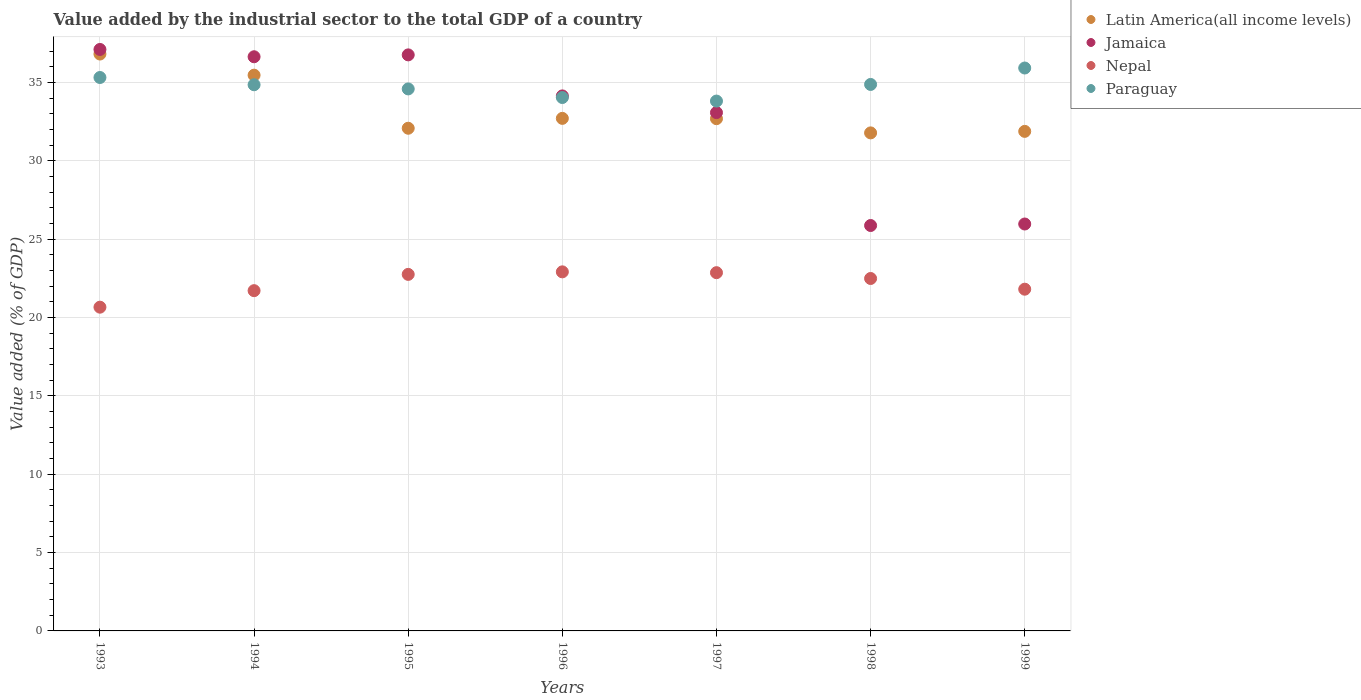What is the value added by the industrial sector to the total GDP in Nepal in 1993?
Offer a very short reply. 20.66. Across all years, what is the maximum value added by the industrial sector to the total GDP in Nepal?
Offer a terse response. 22.92. Across all years, what is the minimum value added by the industrial sector to the total GDP in Nepal?
Provide a succinct answer. 20.66. What is the total value added by the industrial sector to the total GDP in Nepal in the graph?
Make the answer very short. 155.21. What is the difference between the value added by the industrial sector to the total GDP in Nepal in 1993 and that in 1999?
Ensure brevity in your answer.  -1.15. What is the difference between the value added by the industrial sector to the total GDP in Latin America(all income levels) in 1998 and the value added by the industrial sector to the total GDP in Paraguay in 1999?
Provide a succinct answer. -4.14. What is the average value added by the industrial sector to the total GDP in Jamaica per year?
Offer a terse response. 32.8. In the year 1994, what is the difference between the value added by the industrial sector to the total GDP in Paraguay and value added by the industrial sector to the total GDP in Latin America(all income levels)?
Ensure brevity in your answer.  -0.61. In how many years, is the value added by the industrial sector to the total GDP in Jamaica greater than 7 %?
Your response must be concise. 7. What is the ratio of the value added by the industrial sector to the total GDP in Paraguay in 1995 to that in 1996?
Offer a terse response. 1.02. What is the difference between the highest and the second highest value added by the industrial sector to the total GDP in Paraguay?
Offer a very short reply. 0.61. What is the difference between the highest and the lowest value added by the industrial sector to the total GDP in Jamaica?
Make the answer very short. 11.24. Is the sum of the value added by the industrial sector to the total GDP in Jamaica in 1995 and 1999 greater than the maximum value added by the industrial sector to the total GDP in Latin America(all income levels) across all years?
Give a very brief answer. Yes. Is it the case that in every year, the sum of the value added by the industrial sector to the total GDP in Jamaica and value added by the industrial sector to the total GDP in Nepal  is greater than the value added by the industrial sector to the total GDP in Paraguay?
Your answer should be compact. Yes. Does the value added by the industrial sector to the total GDP in Jamaica monotonically increase over the years?
Ensure brevity in your answer.  No. Is the value added by the industrial sector to the total GDP in Jamaica strictly less than the value added by the industrial sector to the total GDP in Latin America(all income levels) over the years?
Your answer should be compact. No. What is the difference between two consecutive major ticks on the Y-axis?
Offer a terse response. 5. Does the graph contain any zero values?
Ensure brevity in your answer.  No. Does the graph contain grids?
Offer a very short reply. Yes. How are the legend labels stacked?
Provide a short and direct response. Vertical. What is the title of the graph?
Offer a terse response. Value added by the industrial sector to the total GDP of a country. What is the label or title of the Y-axis?
Give a very brief answer. Value added (% of GDP). What is the Value added (% of GDP) of Latin America(all income levels) in 1993?
Your answer should be compact. 36.82. What is the Value added (% of GDP) of Jamaica in 1993?
Offer a very short reply. 37.11. What is the Value added (% of GDP) in Nepal in 1993?
Provide a succinct answer. 20.66. What is the Value added (% of GDP) in Paraguay in 1993?
Your answer should be very brief. 35.32. What is the Value added (% of GDP) in Latin America(all income levels) in 1994?
Give a very brief answer. 35.47. What is the Value added (% of GDP) of Jamaica in 1994?
Provide a succinct answer. 36.64. What is the Value added (% of GDP) of Nepal in 1994?
Ensure brevity in your answer.  21.72. What is the Value added (% of GDP) in Paraguay in 1994?
Ensure brevity in your answer.  34.86. What is the Value added (% of GDP) in Latin America(all income levels) in 1995?
Your answer should be very brief. 32.08. What is the Value added (% of GDP) of Jamaica in 1995?
Provide a succinct answer. 36.76. What is the Value added (% of GDP) of Nepal in 1995?
Ensure brevity in your answer.  22.75. What is the Value added (% of GDP) of Paraguay in 1995?
Ensure brevity in your answer.  34.59. What is the Value added (% of GDP) of Latin America(all income levels) in 1996?
Offer a terse response. 32.71. What is the Value added (% of GDP) of Jamaica in 1996?
Your answer should be compact. 34.14. What is the Value added (% of GDP) of Nepal in 1996?
Provide a succinct answer. 22.92. What is the Value added (% of GDP) of Paraguay in 1996?
Provide a short and direct response. 34.04. What is the Value added (% of GDP) of Latin America(all income levels) in 1997?
Ensure brevity in your answer.  32.69. What is the Value added (% of GDP) of Jamaica in 1997?
Your answer should be very brief. 33.08. What is the Value added (% of GDP) in Nepal in 1997?
Provide a succinct answer. 22.86. What is the Value added (% of GDP) in Paraguay in 1997?
Give a very brief answer. 33.82. What is the Value added (% of GDP) of Latin America(all income levels) in 1998?
Keep it short and to the point. 31.78. What is the Value added (% of GDP) of Jamaica in 1998?
Make the answer very short. 25.87. What is the Value added (% of GDP) in Nepal in 1998?
Your answer should be compact. 22.49. What is the Value added (% of GDP) of Paraguay in 1998?
Offer a very short reply. 34.88. What is the Value added (% of GDP) of Latin America(all income levels) in 1999?
Ensure brevity in your answer.  31.88. What is the Value added (% of GDP) in Jamaica in 1999?
Offer a very short reply. 25.97. What is the Value added (% of GDP) in Nepal in 1999?
Your answer should be compact. 21.81. What is the Value added (% of GDP) of Paraguay in 1999?
Your response must be concise. 35.93. Across all years, what is the maximum Value added (% of GDP) in Latin America(all income levels)?
Keep it short and to the point. 36.82. Across all years, what is the maximum Value added (% of GDP) in Jamaica?
Offer a terse response. 37.11. Across all years, what is the maximum Value added (% of GDP) in Nepal?
Offer a terse response. 22.92. Across all years, what is the maximum Value added (% of GDP) of Paraguay?
Give a very brief answer. 35.93. Across all years, what is the minimum Value added (% of GDP) of Latin America(all income levels)?
Give a very brief answer. 31.78. Across all years, what is the minimum Value added (% of GDP) in Jamaica?
Keep it short and to the point. 25.87. Across all years, what is the minimum Value added (% of GDP) of Nepal?
Provide a short and direct response. 20.66. Across all years, what is the minimum Value added (% of GDP) of Paraguay?
Your answer should be very brief. 33.82. What is the total Value added (% of GDP) in Latin America(all income levels) in the graph?
Offer a terse response. 233.44. What is the total Value added (% of GDP) in Jamaica in the graph?
Your response must be concise. 229.58. What is the total Value added (% of GDP) in Nepal in the graph?
Provide a succinct answer. 155.21. What is the total Value added (% of GDP) in Paraguay in the graph?
Provide a succinct answer. 243.43. What is the difference between the Value added (% of GDP) in Latin America(all income levels) in 1993 and that in 1994?
Your response must be concise. 1.35. What is the difference between the Value added (% of GDP) in Jamaica in 1993 and that in 1994?
Provide a succinct answer. 0.47. What is the difference between the Value added (% of GDP) of Nepal in 1993 and that in 1994?
Make the answer very short. -1.05. What is the difference between the Value added (% of GDP) in Paraguay in 1993 and that in 1994?
Provide a short and direct response. 0.46. What is the difference between the Value added (% of GDP) of Latin America(all income levels) in 1993 and that in 1995?
Make the answer very short. 4.74. What is the difference between the Value added (% of GDP) of Jamaica in 1993 and that in 1995?
Make the answer very short. 0.35. What is the difference between the Value added (% of GDP) of Nepal in 1993 and that in 1995?
Your answer should be compact. -2.09. What is the difference between the Value added (% of GDP) of Paraguay in 1993 and that in 1995?
Provide a succinct answer. 0.73. What is the difference between the Value added (% of GDP) of Latin America(all income levels) in 1993 and that in 1996?
Your answer should be very brief. 4.11. What is the difference between the Value added (% of GDP) in Jamaica in 1993 and that in 1996?
Your response must be concise. 2.96. What is the difference between the Value added (% of GDP) in Nepal in 1993 and that in 1996?
Your response must be concise. -2.25. What is the difference between the Value added (% of GDP) of Paraguay in 1993 and that in 1996?
Your answer should be very brief. 1.28. What is the difference between the Value added (% of GDP) in Latin America(all income levels) in 1993 and that in 1997?
Your answer should be very brief. 4.13. What is the difference between the Value added (% of GDP) in Jamaica in 1993 and that in 1997?
Your answer should be very brief. 4.03. What is the difference between the Value added (% of GDP) of Nepal in 1993 and that in 1997?
Provide a short and direct response. -2.2. What is the difference between the Value added (% of GDP) of Paraguay in 1993 and that in 1997?
Give a very brief answer. 1.5. What is the difference between the Value added (% of GDP) of Latin America(all income levels) in 1993 and that in 1998?
Your answer should be very brief. 5.03. What is the difference between the Value added (% of GDP) of Jamaica in 1993 and that in 1998?
Keep it short and to the point. 11.24. What is the difference between the Value added (% of GDP) of Nepal in 1993 and that in 1998?
Provide a succinct answer. -1.83. What is the difference between the Value added (% of GDP) of Paraguay in 1993 and that in 1998?
Keep it short and to the point. 0.44. What is the difference between the Value added (% of GDP) of Latin America(all income levels) in 1993 and that in 1999?
Keep it short and to the point. 4.94. What is the difference between the Value added (% of GDP) in Jamaica in 1993 and that in 1999?
Ensure brevity in your answer.  11.14. What is the difference between the Value added (% of GDP) of Nepal in 1993 and that in 1999?
Offer a terse response. -1.15. What is the difference between the Value added (% of GDP) in Paraguay in 1993 and that in 1999?
Your answer should be compact. -0.61. What is the difference between the Value added (% of GDP) in Latin America(all income levels) in 1994 and that in 1995?
Keep it short and to the point. 3.39. What is the difference between the Value added (% of GDP) in Jamaica in 1994 and that in 1995?
Give a very brief answer. -0.12. What is the difference between the Value added (% of GDP) of Nepal in 1994 and that in 1995?
Provide a succinct answer. -1.04. What is the difference between the Value added (% of GDP) in Paraguay in 1994 and that in 1995?
Your response must be concise. 0.27. What is the difference between the Value added (% of GDP) of Latin America(all income levels) in 1994 and that in 1996?
Provide a short and direct response. 2.76. What is the difference between the Value added (% of GDP) of Jamaica in 1994 and that in 1996?
Your response must be concise. 2.5. What is the difference between the Value added (% of GDP) of Nepal in 1994 and that in 1996?
Keep it short and to the point. -1.2. What is the difference between the Value added (% of GDP) in Paraguay in 1994 and that in 1996?
Your answer should be compact. 0.81. What is the difference between the Value added (% of GDP) of Latin America(all income levels) in 1994 and that in 1997?
Offer a terse response. 2.78. What is the difference between the Value added (% of GDP) of Jamaica in 1994 and that in 1997?
Your answer should be compact. 3.56. What is the difference between the Value added (% of GDP) in Nepal in 1994 and that in 1997?
Make the answer very short. -1.15. What is the difference between the Value added (% of GDP) in Paraguay in 1994 and that in 1997?
Your answer should be compact. 1.04. What is the difference between the Value added (% of GDP) in Latin America(all income levels) in 1994 and that in 1998?
Your answer should be compact. 3.68. What is the difference between the Value added (% of GDP) in Jamaica in 1994 and that in 1998?
Provide a succinct answer. 10.77. What is the difference between the Value added (% of GDP) in Nepal in 1994 and that in 1998?
Offer a very short reply. -0.78. What is the difference between the Value added (% of GDP) in Paraguay in 1994 and that in 1998?
Provide a short and direct response. -0.02. What is the difference between the Value added (% of GDP) of Latin America(all income levels) in 1994 and that in 1999?
Offer a terse response. 3.59. What is the difference between the Value added (% of GDP) of Jamaica in 1994 and that in 1999?
Make the answer very short. 10.67. What is the difference between the Value added (% of GDP) in Nepal in 1994 and that in 1999?
Your response must be concise. -0.09. What is the difference between the Value added (% of GDP) in Paraguay in 1994 and that in 1999?
Offer a terse response. -1.07. What is the difference between the Value added (% of GDP) of Latin America(all income levels) in 1995 and that in 1996?
Ensure brevity in your answer.  -0.63. What is the difference between the Value added (% of GDP) of Jamaica in 1995 and that in 1996?
Offer a very short reply. 2.62. What is the difference between the Value added (% of GDP) of Nepal in 1995 and that in 1996?
Offer a terse response. -0.16. What is the difference between the Value added (% of GDP) in Paraguay in 1995 and that in 1996?
Keep it short and to the point. 0.55. What is the difference between the Value added (% of GDP) in Latin America(all income levels) in 1995 and that in 1997?
Provide a short and direct response. -0.61. What is the difference between the Value added (% of GDP) in Jamaica in 1995 and that in 1997?
Your response must be concise. 3.68. What is the difference between the Value added (% of GDP) of Nepal in 1995 and that in 1997?
Your answer should be compact. -0.11. What is the difference between the Value added (% of GDP) in Paraguay in 1995 and that in 1997?
Make the answer very short. 0.78. What is the difference between the Value added (% of GDP) in Latin America(all income levels) in 1995 and that in 1998?
Make the answer very short. 0.3. What is the difference between the Value added (% of GDP) of Jamaica in 1995 and that in 1998?
Offer a very short reply. 10.89. What is the difference between the Value added (% of GDP) in Nepal in 1995 and that in 1998?
Keep it short and to the point. 0.26. What is the difference between the Value added (% of GDP) in Paraguay in 1995 and that in 1998?
Ensure brevity in your answer.  -0.29. What is the difference between the Value added (% of GDP) in Latin America(all income levels) in 1995 and that in 1999?
Make the answer very short. 0.2. What is the difference between the Value added (% of GDP) in Jamaica in 1995 and that in 1999?
Keep it short and to the point. 10.79. What is the difference between the Value added (% of GDP) of Nepal in 1995 and that in 1999?
Your answer should be very brief. 0.95. What is the difference between the Value added (% of GDP) of Paraguay in 1995 and that in 1999?
Your response must be concise. -1.33. What is the difference between the Value added (% of GDP) of Latin America(all income levels) in 1996 and that in 1997?
Provide a short and direct response. 0.02. What is the difference between the Value added (% of GDP) of Jamaica in 1996 and that in 1997?
Offer a very short reply. 1.07. What is the difference between the Value added (% of GDP) of Nepal in 1996 and that in 1997?
Offer a very short reply. 0.05. What is the difference between the Value added (% of GDP) in Paraguay in 1996 and that in 1997?
Keep it short and to the point. 0.23. What is the difference between the Value added (% of GDP) of Latin America(all income levels) in 1996 and that in 1998?
Ensure brevity in your answer.  0.93. What is the difference between the Value added (% of GDP) of Jamaica in 1996 and that in 1998?
Ensure brevity in your answer.  8.27. What is the difference between the Value added (% of GDP) in Nepal in 1996 and that in 1998?
Offer a terse response. 0.42. What is the difference between the Value added (% of GDP) in Paraguay in 1996 and that in 1998?
Offer a terse response. -0.83. What is the difference between the Value added (% of GDP) in Latin America(all income levels) in 1996 and that in 1999?
Your answer should be very brief. 0.83. What is the difference between the Value added (% of GDP) in Jamaica in 1996 and that in 1999?
Provide a succinct answer. 8.18. What is the difference between the Value added (% of GDP) in Nepal in 1996 and that in 1999?
Your response must be concise. 1.11. What is the difference between the Value added (% of GDP) in Paraguay in 1996 and that in 1999?
Keep it short and to the point. -1.88. What is the difference between the Value added (% of GDP) of Latin America(all income levels) in 1997 and that in 1998?
Make the answer very short. 0.91. What is the difference between the Value added (% of GDP) in Jamaica in 1997 and that in 1998?
Your answer should be compact. 7.21. What is the difference between the Value added (% of GDP) in Nepal in 1997 and that in 1998?
Offer a very short reply. 0.37. What is the difference between the Value added (% of GDP) of Paraguay in 1997 and that in 1998?
Offer a very short reply. -1.06. What is the difference between the Value added (% of GDP) of Latin America(all income levels) in 1997 and that in 1999?
Ensure brevity in your answer.  0.81. What is the difference between the Value added (% of GDP) in Jamaica in 1997 and that in 1999?
Provide a succinct answer. 7.11. What is the difference between the Value added (% of GDP) in Nepal in 1997 and that in 1999?
Provide a short and direct response. 1.05. What is the difference between the Value added (% of GDP) in Paraguay in 1997 and that in 1999?
Give a very brief answer. -2.11. What is the difference between the Value added (% of GDP) of Latin America(all income levels) in 1998 and that in 1999?
Your response must be concise. -0.1. What is the difference between the Value added (% of GDP) of Jamaica in 1998 and that in 1999?
Give a very brief answer. -0.1. What is the difference between the Value added (% of GDP) of Nepal in 1998 and that in 1999?
Ensure brevity in your answer.  0.68. What is the difference between the Value added (% of GDP) in Paraguay in 1998 and that in 1999?
Provide a succinct answer. -1.05. What is the difference between the Value added (% of GDP) in Latin America(all income levels) in 1993 and the Value added (% of GDP) in Jamaica in 1994?
Give a very brief answer. 0.17. What is the difference between the Value added (% of GDP) in Latin America(all income levels) in 1993 and the Value added (% of GDP) in Nepal in 1994?
Keep it short and to the point. 15.1. What is the difference between the Value added (% of GDP) of Latin America(all income levels) in 1993 and the Value added (% of GDP) of Paraguay in 1994?
Ensure brevity in your answer.  1.96. What is the difference between the Value added (% of GDP) of Jamaica in 1993 and the Value added (% of GDP) of Nepal in 1994?
Make the answer very short. 15.39. What is the difference between the Value added (% of GDP) in Jamaica in 1993 and the Value added (% of GDP) in Paraguay in 1994?
Your answer should be very brief. 2.25. What is the difference between the Value added (% of GDP) of Nepal in 1993 and the Value added (% of GDP) of Paraguay in 1994?
Offer a terse response. -14.2. What is the difference between the Value added (% of GDP) in Latin America(all income levels) in 1993 and the Value added (% of GDP) in Jamaica in 1995?
Provide a succinct answer. 0.05. What is the difference between the Value added (% of GDP) in Latin America(all income levels) in 1993 and the Value added (% of GDP) in Nepal in 1995?
Provide a succinct answer. 14.06. What is the difference between the Value added (% of GDP) of Latin America(all income levels) in 1993 and the Value added (% of GDP) of Paraguay in 1995?
Ensure brevity in your answer.  2.23. What is the difference between the Value added (% of GDP) of Jamaica in 1993 and the Value added (% of GDP) of Nepal in 1995?
Your response must be concise. 14.35. What is the difference between the Value added (% of GDP) in Jamaica in 1993 and the Value added (% of GDP) in Paraguay in 1995?
Provide a short and direct response. 2.52. What is the difference between the Value added (% of GDP) of Nepal in 1993 and the Value added (% of GDP) of Paraguay in 1995?
Offer a very short reply. -13.93. What is the difference between the Value added (% of GDP) of Latin America(all income levels) in 1993 and the Value added (% of GDP) of Jamaica in 1996?
Keep it short and to the point. 2.67. What is the difference between the Value added (% of GDP) in Latin America(all income levels) in 1993 and the Value added (% of GDP) in Nepal in 1996?
Offer a terse response. 13.9. What is the difference between the Value added (% of GDP) of Latin America(all income levels) in 1993 and the Value added (% of GDP) of Paraguay in 1996?
Your answer should be very brief. 2.78. What is the difference between the Value added (% of GDP) of Jamaica in 1993 and the Value added (% of GDP) of Nepal in 1996?
Keep it short and to the point. 14.19. What is the difference between the Value added (% of GDP) of Jamaica in 1993 and the Value added (% of GDP) of Paraguay in 1996?
Ensure brevity in your answer.  3.07. What is the difference between the Value added (% of GDP) in Nepal in 1993 and the Value added (% of GDP) in Paraguay in 1996?
Make the answer very short. -13.38. What is the difference between the Value added (% of GDP) in Latin America(all income levels) in 1993 and the Value added (% of GDP) in Jamaica in 1997?
Make the answer very short. 3.74. What is the difference between the Value added (% of GDP) of Latin America(all income levels) in 1993 and the Value added (% of GDP) of Nepal in 1997?
Ensure brevity in your answer.  13.95. What is the difference between the Value added (% of GDP) of Latin America(all income levels) in 1993 and the Value added (% of GDP) of Paraguay in 1997?
Give a very brief answer. 3. What is the difference between the Value added (% of GDP) in Jamaica in 1993 and the Value added (% of GDP) in Nepal in 1997?
Your answer should be compact. 14.25. What is the difference between the Value added (% of GDP) in Jamaica in 1993 and the Value added (% of GDP) in Paraguay in 1997?
Ensure brevity in your answer.  3.29. What is the difference between the Value added (% of GDP) of Nepal in 1993 and the Value added (% of GDP) of Paraguay in 1997?
Provide a succinct answer. -13.15. What is the difference between the Value added (% of GDP) in Latin America(all income levels) in 1993 and the Value added (% of GDP) in Jamaica in 1998?
Provide a succinct answer. 10.94. What is the difference between the Value added (% of GDP) in Latin America(all income levels) in 1993 and the Value added (% of GDP) in Nepal in 1998?
Ensure brevity in your answer.  14.32. What is the difference between the Value added (% of GDP) of Latin America(all income levels) in 1993 and the Value added (% of GDP) of Paraguay in 1998?
Keep it short and to the point. 1.94. What is the difference between the Value added (% of GDP) in Jamaica in 1993 and the Value added (% of GDP) in Nepal in 1998?
Make the answer very short. 14.62. What is the difference between the Value added (% of GDP) of Jamaica in 1993 and the Value added (% of GDP) of Paraguay in 1998?
Ensure brevity in your answer.  2.23. What is the difference between the Value added (% of GDP) of Nepal in 1993 and the Value added (% of GDP) of Paraguay in 1998?
Make the answer very short. -14.22. What is the difference between the Value added (% of GDP) of Latin America(all income levels) in 1993 and the Value added (% of GDP) of Jamaica in 1999?
Keep it short and to the point. 10.85. What is the difference between the Value added (% of GDP) of Latin America(all income levels) in 1993 and the Value added (% of GDP) of Nepal in 1999?
Offer a terse response. 15.01. What is the difference between the Value added (% of GDP) in Latin America(all income levels) in 1993 and the Value added (% of GDP) in Paraguay in 1999?
Ensure brevity in your answer.  0.89. What is the difference between the Value added (% of GDP) in Jamaica in 1993 and the Value added (% of GDP) in Paraguay in 1999?
Give a very brief answer. 1.18. What is the difference between the Value added (% of GDP) in Nepal in 1993 and the Value added (% of GDP) in Paraguay in 1999?
Make the answer very short. -15.26. What is the difference between the Value added (% of GDP) of Latin America(all income levels) in 1994 and the Value added (% of GDP) of Jamaica in 1995?
Provide a succinct answer. -1.29. What is the difference between the Value added (% of GDP) of Latin America(all income levels) in 1994 and the Value added (% of GDP) of Nepal in 1995?
Your answer should be very brief. 12.71. What is the difference between the Value added (% of GDP) in Latin America(all income levels) in 1994 and the Value added (% of GDP) in Paraguay in 1995?
Your answer should be very brief. 0.88. What is the difference between the Value added (% of GDP) in Jamaica in 1994 and the Value added (% of GDP) in Nepal in 1995?
Provide a succinct answer. 13.89. What is the difference between the Value added (% of GDP) of Jamaica in 1994 and the Value added (% of GDP) of Paraguay in 1995?
Keep it short and to the point. 2.05. What is the difference between the Value added (% of GDP) in Nepal in 1994 and the Value added (% of GDP) in Paraguay in 1995?
Keep it short and to the point. -12.88. What is the difference between the Value added (% of GDP) of Latin America(all income levels) in 1994 and the Value added (% of GDP) of Jamaica in 1996?
Ensure brevity in your answer.  1.32. What is the difference between the Value added (% of GDP) in Latin America(all income levels) in 1994 and the Value added (% of GDP) in Nepal in 1996?
Keep it short and to the point. 12.55. What is the difference between the Value added (% of GDP) of Latin America(all income levels) in 1994 and the Value added (% of GDP) of Paraguay in 1996?
Your answer should be compact. 1.43. What is the difference between the Value added (% of GDP) in Jamaica in 1994 and the Value added (% of GDP) in Nepal in 1996?
Provide a succinct answer. 13.73. What is the difference between the Value added (% of GDP) in Jamaica in 1994 and the Value added (% of GDP) in Paraguay in 1996?
Give a very brief answer. 2.6. What is the difference between the Value added (% of GDP) in Nepal in 1994 and the Value added (% of GDP) in Paraguay in 1996?
Offer a very short reply. -12.33. What is the difference between the Value added (% of GDP) in Latin America(all income levels) in 1994 and the Value added (% of GDP) in Jamaica in 1997?
Your answer should be very brief. 2.39. What is the difference between the Value added (% of GDP) of Latin America(all income levels) in 1994 and the Value added (% of GDP) of Nepal in 1997?
Offer a very short reply. 12.6. What is the difference between the Value added (% of GDP) of Latin America(all income levels) in 1994 and the Value added (% of GDP) of Paraguay in 1997?
Offer a terse response. 1.65. What is the difference between the Value added (% of GDP) in Jamaica in 1994 and the Value added (% of GDP) in Nepal in 1997?
Give a very brief answer. 13.78. What is the difference between the Value added (% of GDP) in Jamaica in 1994 and the Value added (% of GDP) in Paraguay in 1997?
Your response must be concise. 2.83. What is the difference between the Value added (% of GDP) of Nepal in 1994 and the Value added (% of GDP) of Paraguay in 1997?
Ensure brevity in your answer.  -12.1. What is the difference between the Value added (% of GDP) of Latin America(all income levels) in 1994 and the Value added (% of GDP) of Jamaica in 1998?
Offer a terse response. 9.59. What is the difference between the Value added (% of GDP) of Latin America(all income levels) in 1994 and the Value added (% of GDP) of Nepal in 1998?
Make the answer very short. 12.98. What is the difference between the Value added (% of GDP) of Latin America(all income levels) in 1994 and the Value added (% of GDP) of Paraguay in 1998?
Provide a short and direct response. 0.59. What is the difference between the Value added (% of GDP) of Jamaica in 1994 and the Value added (% of GDP) of Nepal in 1998?
Provide a short and direct response. 14.15. What is the difference between the Value added (% of GDP) of Jamaica in 1994 and the Value added (% of GDP) of Paraguay in 1998?
Your answer should be compact. 1.77. What is the difference between the Value added (% of GDP) of Nepal in 1994 and the Value added (% of GDP) of Paraguay in 1998?
Give a very brief answer. -13.16. What is the difference between the Value added (% of GDP) in Latin America(all income levels) in 1994 and the Value added (% of GDP) in Jamaica in 1999?
Make the answer very short. 9.5. What is the difference between the Value added (% of GDP) of Latin America(all income levels) in 1994 and the Value added (% of GDP) of Nepal in 1999?
Provide a short and direct response. 13.66. What is the difference between the Value added (% of GDP) of Latin America(all income levels) in 1994 and the Value added (% of GDP) of Paraguay in 1999?
Provide a short and direct response. -0.46. What is the difference between the Value added (% of GDP) in Jamaica in 1994 and the Value added (% of GDP) in Nepal in 1999?
Your response must be concise. 14.83. What is the difference between the Value added (% of GDP) of Jamaica in 1994 and the Value added (% of GDP) of Paraguay in 1999?
Your response must be concise. 0.72. What is the difference between the Value added (% of GDP) of Nepal in 1994 and the Value added (% of GDP) of Paraguay in 1999?
Offer a very short reply. -14.21. What is the difference between the Value added (% of GDP) in Latin America(all income levels) in 1995 and the Value added (% of GDP) in Jamaica in 1996?
Provide a short and direct response. -2.06. What is the difference between the Value added (% of GDP) in Latin America(all income levels) in 1995 and the Value added (% of GDP) in Nepal in 1996?
Provide a short and direct response. 9.16. What is the difference between the Value added (% of GDP) of Latin America(all income levels) in 1995 and the Value added (% of GDP) of Paraguay in 1996?
Provide a short and direct response. -1.96. What is the difference between the Value added (% of GDP) in Jamaica in 1995 and the Value added (% of GDP) in Nepal in 1996?
Give a very brief answer. 13.85. What is the difference between the Value added (% of GDP) in Jamaica in 1995 and the Value added (% of GDP) in Paraguay in 1996?
Offer a very short reply. 2.72. What is the difference between the Value added (% of GDP) in Nepal in 1995 and the Value added (% of GDP) in Paraguay in 1996?
Provide a succinct answer. -11.29. What is the difference between the Value added (% of GDP) of Latin America(all income levels) in 1995 and the Value added (% of GDP) of Jamaica in 1997?
Ensure brevity in your answer.  -1. What is the difference between the Value added (% of GDP) of Latin America(all income levels) in 1995 and the Value added (% of GDP) of Nepal in 1997?
Ensure brevity in your answer.  9.22. What is the difference between the Value added (% of GDP) in Latin America(all income levels) in 1995 and the Value added (% of GDP) in Paraguay in 1997?
Keep it short and to the point. -1.73. What is the difference between the Value added (% of GDP) in Jamaica in 1995 and the Value added (% of GDP) in Nepal in 1997?
Keep it short and to the point. 13.9. What is the difference between the Value added (% of GDP) in Jamaica in 1995 and the Value added (% of GDP) in Paraguay in 1997?
Keep it short and to the point. 2.95. What is the difference between the Value added (% of GDP) in Nepal in 1995 and the Value added (% of GDP) in Paraguay in 1997?
Provide a short and direct response. -11.06. What is the difference between the Value added (% of GDP) in Latin America(all income levels) in 1995 and the Value added (% of GDP) in Jamaica in 1998?
Provide a short and direct response. 6.21. What is the difference between the Value added (% of GDP) in Latin America(all income levels) in 1995 and the Value added (% of GDP) in Nepal in 1998?
Offer a very short reply. 9.59. What is the difference between the Value added (% of GDP) in Latin America(all income levels) in 1995 and the Value added (% of GDP) in Paraguay in 1998?
Keep it short and to the point. -2.8. What is the difference between the Value added (% of GDP) of Jamaica in 1995 and the Value added (% of GDP) of Nepal in 1998?
Provide a short and direct response. 14.27. What is the difference between the Value added (% of GDP) in Jamaica in 1995 and the Value added (% of GDP) in Paraguay in 1998?
Ensure brevity in your answer.  1.89. What is the difference between the Value added (% of GDP) of Nepal in 1995 and the Value added (% of GDP) of Paraguay in 1998?
Ensure brevity in your answer.  -12.12. What is the difference between the Value added (% of GDP) in Latin America(all income levels) in 1995 and the Value added (% of GDP) in Jamaica in 1999?
Your response must be concise. 6.11. What is the difference between the Value added (% of GDP) in Latin America(all income levels) in 1995 and the Value added (% of GDP) in Nepal in 1999?
Your answer should be very brief. 10.27. What is the difference between the Value added (% of GDP) of Latin America(all income levels) in 1995 and the Value added (% of GDP) of Paraguay in 1999?
Give a very brief answer. -3.84. What is the difference between the Value added (% of GDP) in Jamaica in 1995 and the Value added (% of GDP) in Nepal in 1999?
Keep it short and to the point. 14.95. What is the difference between the Value added (% of GDP) in Jamaica in 1995 and the Value added (% of GDP) in Paraguay in 1999?
Provide a short and direct response. 0.84. What is the difference between the Value added (% of GDP) of Nepal in 1995 and the Value added (% of GDP) of Paraguay in 1999?
Provide a succinct answer. -13.17. What is the difference between the Value added (% of GDP) in Latin America(all income levels) in 1996 and the Value added (% of GDP) in Jamaica in 1997?
Keep it short and to the point. -0.37. What is the difference between the Value added (% of GDP) of Latin America(all income levels) in 1996 and the Value added (% of GDP) of Nepal in 1997?
Your answer should be very brief. 9.85. What is the difference between the Value added (% of GDP) of Latin America(all income levels) in 1996 and the Value added (% of GDP) of Paraguay in 1997?
Provide a succinct answer. -1.1. What is the difference between the Value added (% of GDP) in Jamaica in 1996 and the Value added (% of GDP) in Nepal in 1997?
Your answer should be compact. 11.28. What is the difference between the Value added (% of GDP) of Jamaica in 1996 and the Value added (% of GDP) of Paraguay in 1997?
Give a very brief answer. 0.33. What is the difference between the Value added (% of GDP) of Nepal in 1996 and the Value added (% of GDP) of Paraguay in 1997?
Provide a short and direct response. -10.9. What is the difference between the Value added (% of GDP) in Latin America(all income levels) in 1996 and the Value added (% of GDP) in Jamaica in 1998?
Your answer should be very brief. 6.84. What is the difference between the Value added (% of GDP) of Latin America(all income levels) in 1996 and the Value added (% of GDP) of Nepal in 1998?
Offer a terse response. 10.22. What is the difference between the Value added (% of GDP) in Latin America(all income levels) in 1996 and the Value added (% of GDP) in Paraguay in 1998?
Keep it short and to the point. -2.17. What is the difference between the Value added (% of GDP) in Jamaica in 1996 and the Value added (% of GDP) in Nepal in 1998?
Ensure brevity in your answer.  11.65. What is the difference between the Value added (% of GDP) of Jamaica in 1996 and the Value added (% of GDP) of Paraguay in 1998?
Provide a succinct answer. -0.73. What is the difference between the Value added (% of GDP) in Nepal in 1996 and the Value added (% of GDP) in Paraguay in 1998?
Provide a short and direct response. -11.96. What is the difference between the Value added (% of GDP) of Latin America(all income levels) in 1996 and the Value added (% of GDP) of Jamaica in 1999?
Give a very brief answer. 6.74. What is the difference between the Value added (% of GDP) in Latin America(all income levels) in 1996 and the Value added (% of GDP) in Nepal in 1999?
Your answer should be compact. 10.9. What is the difference between the Value added (% of GDP) of Latin America(all income levels) in 1996 and the Value added (% of GDP) of Paraguay in 1999?
Offer a terse response. -3.21. What is the difference between the Value added (% of GDP) in Jamaica in 1996 and the Value added (% of GDP) in Nepal in 1999?
Your answer should be very brief. 12.34. What is the difference between the Value added (% of GDP) in Jamaica in 1996 and the Value added (% of GDP) in Paraguay in 1999?
Your answer should be compact. -1.78. What is the difference between the Value added (% of GDP) in Nepal in 1996 and the Value added (% of GDP) in Paraguay in 1999?
Ensure brevity in your answer.  -13.01. What is the difference between the Value added (% of GDP) in Latin America(all income levels) in 1997 and the Value added (% of GDP) in Jamaica in 1998?
Your response must be concise. 6.82. What is the difference between the Value added (% of GDP) in Latin America(all income levels) in 1997 and the Value added (% of GDP) in Nepal in 1998?
Give a very brief answer. 10.2. What is the difference between the Value added (% of GDP) in Latin America(all income levels) in 1997 and the Value added (% of GDP) in Paraguay in 1998?
Your response must be concise. -2.18. What is the difference between the Value added (% of GDP) in Jamaica in 1997 and the Value added (% of GDP) in Nepal in 1998?
Offer a very short reply. 10.59. What is the difference between the Value added (% of GDP) of Jamaica in 1997 and the Value added (% of GDP) of Paraguay in 1998?
Ensure brevity in your answer.  -1.8. What is the difference between the Value added (% of GDP) in Nepal in 1997 and the Value added (% of GDP) in Paraguay in 1998?
Provide a short and direct response. -12.01. What is the difference between the Value added (% of GDP) of Latin America(all income levels) in 1997 and the Value added (% of GDP) of Jamaica in 1999?
Offer a terse response. 6.72. What is the difference between the Value added (% of GDP) of Latin America(all income levels) in 1997 and the Value added (% of GDP) of Nepal in 1999?
Ensure brevity in your answer.  10.88. What is the difference between the Value added (% of GDP) of Latin America(all income levels) in 1997 and the Value added (% of GDP) of Paraguay in 1999?
Give a very brief answer. -3.23. What is the difference between the Value added (% of GDP) of Jamaica in 1997 and the Value added (% of GDP) of Nepal in 1999?
Provide a short and direct response. 11.27. What is the difference between the Value added (% of GDP) in Jamaica in 1997 and the Value added (% of GDP) in Paraguay in 1999?
Your answer should be very brief. -2.85. What is the difference between the Value added (% of GDP) of Nepal in 1997 and the Value added (% of GDP) of Paraguay in 1999?
Provide a succinct answer. -13.06. What is the difference between the Value added (% of GDP) in Latin America(all income levels) in 1998 and the Value added (% of GDP) in Jamaica in 1999?
Provide a short and direct response. 5.82. What is the difference between the Value added (% of GDP) in Latin America(all income levels) in 1998 and the Value added (% of GDP) in Nepal in 1999?
Give a very brief answer. 9.98. What is the difference between the Value added (% of GDP) of Latin America(all income levels) in 1998 and the Value added (% of GDP) of Paraguay in 1999?
Make the answer very short. -4.14. What is the difference between the Value added (% of GDP) of Jamaica in 1998 and the Value added (% of GDP) of Nepal in 1999?
Provide a succinct answer. 4.06. What is the difference between the Value added (% of GDP) in Jamaica in 1998 and the Value added (% of GDP) in Paraguay in 1999?
Make the answer very short. -10.05. What is the difference between the Value added (% of GDP) in Nepal in 1998 and the Value added (% of GDP) in Paraguay in 1999?
Your answer should be very brief. -13.43. What is the average Value added (% of GDP) in Latin America(all income levels) per year?
Your response must be concise. 33.35. What is the average Value added (% of GDP) of Jamaica per year?
Provide a succinct answer. 32.8. What is the average Value added (% of GDP) in Nepal per year?
Make the answer very short. 22.17. What is the average Value added (% of GDP) in Paraguay per year?
Your response must be concise. 34.78. In the year 1993, what is the difference between the Value added (% of GDP) of Latin America(all income levels) and Value added (% of GDP) of Jamaica?
Ensure brevity in your answer.  -0.29. In the year 1993, what is the difference between the Value added (% of GDP) of Latin America(all income levels) and Value added (% of GDP) of Nepal?
Keep it short and to the point. 16.16. In the year 1993, what is the difference between the Value added (% of GDP) of Latin America(all income levels) and Value added (% of GDP) of Paraguay?
Keep it short and to the point. 1.5. In the year 1993, what is the difference between the Value added (% of GDP) of Jamaica and Value added (% of GDP) of Nepal?
Provide a succinct answer. 16.45. In the year 1993, what is the difference between the Value added (% of GDP) of Jamaica and Value added (% of GDP) of Paraguay?
Keep it short and to the point. 1.79. In the year 1993, what is the difference between the Value added (% of GDP) of Nepal and Value added (% of GDP) of Paraguay?
Your answer should be very brief. -14.66. In the year 1994, what is the difference between the Value added (% of GDP) of Latin America(all income levels) and Value added (% of GDP) of Jamaica?
Give a very brief answer. -1.18. In the year 1994, what is the difference between the Value added (% of GDP) of Latin America(all income levels) and Value added (% of GDP) of Nepal?
Your answer should be very brief. 13.75. In the year 1994, what is the difference between the Value added (% of GDP) of Latin America(all income levels) and Value added (% of GDP) of Paraguay?
Keep it short and to the point. 0.61. In the year 1994, what is the difference between the Value added (% of GDP) of Jamaica and Value added (% of GDP) of Nepal?
Ensure brevity in your answer.  14.93. In the year 1994, what is the difference between the Value added (% of GDP) in Jamaica and Value added (% of GDP) in Paraguay?
Keep it short and to the point. 1.79. In the year 1994, what is the difference between the Value added (% of GDP) in Nepal and Value added (% of GDP) in Paraguay?
Provide a short and direct response. -13.14. In the year 1995, what is the difference between the Value added (% of GDP) in Latin America(all income levels) and Value added (% of GDP) in Jamaica?
Offer a very short reply. -4.68. In the year 1995, what is the difference between the Value added (% of GDP) of Latin America(all income levels) and Value added (% of GDP) of Nepal?
Your response must be concise. 9.33. In the year 1995, what is the difference between the Value added (% of GDP) of Latin America(all income levels) and Value added (% of GDP) of Paraguay?
Your answer should be very brief. -2.51. In the year 1995, what is the difference between the Value added (% of GDP) of Jamaica and Value added (% of GDP) of Nepal?
Offer a very short reply. 14.01. In the year 1995, what is the difference between the Value added (% of GDP) of Jamaica and Value added (% of GDP) of Paraguay?
Provide a succinct answer. 2.17. In the year 1995, what is the difference between the Value added (% of GDP) in Nepal and Value added (% of GDP) in Paraguay?
Your answer should be compact. -11.84. In the year 1996, what is the difference between the Value added (% of GDP) of Latin America(all income levels) and Value added (% of GDP) of Jamaica?
Make the answer very short. -1.43. In the year 1996, what is the difference between the Value added (% of GDP) of Latin America(all income levels) and Value added (% of GDP) of Nepal?
Offer a terse response. 9.8. In the year 1996, what is the difference between the Value added (% of GDP) in Latin America(all income levels) and Value added (% of GDP) in Paraguay?
Offer a terse response. -1.33. In the year 1996, what is the difference between the Value added (% of GDP) of Jamaica and Value added (% of GDP) of Nepal?
Give a very brief answer. 11.23. In the year 1996, what is the difference between the Value added (% of GDP) of Jamaica and Value added (% of GDP) of Paraguay?
Provide a short and direct response. 0.1. In the year 1996, what is the difference between the Value added (% of GDP) of Nepal and Value added (% of GDP) of Paraguay?
Offer a terse response. -11.13. In the year 1997, what is the difference between the Value added (% of GDP) of Latin America(all income levels) and Value added (% of GDP) of Jamaica?
Offer a very short reply. -0.39. In the year 1997, what is the difference between the Value added (% of GDP) in Latin America(all income levels) and Value added (% of GDP) in Nepal?
Your answer should be very brief. 9.83. In the year 1997, what is the difference between the Value added (% of GDP) in Latin America(all income levels) and Value added (% of GDP) in Paraguay?
Keep it short and to the point. -1.12. In the year 1997, what is the difference between the Value added (% of GDP) of Jamaica and Value added (% of GDP) of Nepal?
Offer a very short reply. 10.22. In the year 1997, what is the difference between the Value added (% of GDP) in Jamaica and Value added (% of GDP) in Paraguay?
Keep it short and to the point. -0.74. In the year 1997, what is the difference between the Value added (% of GDP) of Nepal and Value added (% of GDP) of Paraguay?
Ensure brevity in your answer.  -10.95. In the year 1998, what is the difference between the Value added (% of GDP) of Latin America(all income levels) and Value added (% of GDP) of Jamaica?
Make the answer very short. 5.91. In the year 1998, what is the difference between the Value added (% of GDP) of Latin America(all income levels) and Value added (% of GDP) of Nepal?
Provide a short and direct response. 9.29. In the year 1998, what is the difference between the Value added (% of GDP) of Latin America(all income levels) and Value added (% of GDP) of Paraguay?
Offer a terse response. -3.09. In the year 1998, what is the difference between the Value added (% of GDP) of Jamaica and Value added (% of GDP) of Nepal?
Ensure brevity in your answer.  3.38. In the year 1998, what is the difference between the Value added (% of GDP) of Jamaica and Value added (% of GDP) of Paraguay?
Ensure brevity in your answer.  -9. In the year 1998, what is the difference between the Value added (% of GDP) of Nepal and Value added (% of GDP) of Paraguay?
Make the answer very short. -12.38. In the year 1999, what is the difference between the Value added (% of GDP) of Latin America(all income levels) and Value added (% of GDP) of Jamaica?
Your response must be concise. 5.91. In the year 1999, what is the difference between the Value added (% of GDP) in Latin America(all income levels) and Value added (% of GDP) in Nepal?
Provide a short and direct response. 10.07. In the year 1999, what is the difference between the Value added (% of GDP) in Latin America(all income levels) and Value added (% of GDP) in Paraguay?
Provide a succinct answer. -4.04. In the year 1999, what is the difference between the Value added (% of GDP) in Jamaica and Value added (% of GDP) in Nepal?
Offer a very short reply. 4.16. In the year 1999, what is the difference between the Value added (% of GDP) of Jamaica and Value added (% of GDP) of Paraguay?
Make the answer very short. -9.96. In the year 1999, what is the difference between the Value added (% of GDP) in Nepal and Value added (% of GDP) in Paraguay?
Ensure brevity in your answer.  -14.12. What is the ratio of the Value added (% of GDP) in Latin America(all income levels) in 1993 to that in 1994?
Keep it short and to the point. 1.04. What is the ratio of the Value added (% of GDP) of Jamaica in 1993 to that in 1994?
Offer a terse response. 1.01. What is the ratio of the Value added (% of GDP) in Nepal in 1993 to that in 1994?
Your response must be concise. 0.95. What is the ratio of the Value added (% of GDP) of Paraguay in 1993 to that in 1994?
Make the answer very short. 1.01. What is the ratio of the Value added (% of GDP) in Latin America(all income levels) in 1993 to that in 1995?
Offer a terse response. 1.15. What is the ratio of the Value added (% of GDP) of Jamaica in 1993 to that in 1995?
Give a very brief answer. 1.01. What is the ratio of the Value added (% of GDP) in Nepal in 1993 to that in 1995?
Give a very brief answer. 0.91. What is the ratio of the Value added (% of GDP) of Paraguay in 1993 to that in 1995?
Your answer should be very brief. 1.02. What is the ratio of the Value added (% of GDP) in Latin America(all income levels) in 1993 to that in 1996?
Your response must be concise. 1.13. What is the ratio of the Value added (% of GDP) in Jamaica in 1993 to that in 1996?
Give a very brief answer. 1.09. What is the ratio of the Value added (% of GDP) of Nepal in 1993 to that in 1996?
Offer a terse response. 0.9. What is the ratio of the Value added (% of GDP) of Paraguay in 1993 to that in 1996?
Your answer should be very brief. 1.04. What is the ratio of the Value added (% of GDP) in Latin America(all income levels) in 1993 to that in 1997?
Make the answer very short. 1.13. What is the ratio of the Value added (% of GDP) in Jamaica in 1993 to that in 1997?
Your response must be concise. 1.12. What is the ratio of the Value added (% of GDP) in Nepal in 1993 to that in 1997?
Your answer should be compact. 0.9. What is the ratio of the Value added (% of GDP) of Paraguay in 1993 to that in 1997?
Provide a short and direct response. 1.04. What is the ratio of the Value added (% of GDP) in Latin America(all income levels) in 1993 to that in 1998?
Offer a terse response. 1.16. What is the ratio of the Value added (% of GDP) of Jamaica in 1993 to that in 1998?
Provide a succinct answer. 1.43. What is the ratio of the Value added (% of GDP) in Nepal in 1993 to that in 1998?
Offer a terse response. 0.92. What is the ratio of the Value added (% of GDP) in Paraguay in 1993 to that in 1998?
Your response must be concise. 1.01. What is the ratio of the Value added (% of GDP) in Latin America(all income levels) in 1993 to that in 1999?
Offer a very short reply. 1.15. What is the ratio of the Value added (% of GDP) in Jamaica in 1993 to that in 1999?
Make the answer very short. 1.43. What is the ratio of the Value added (% of GDP) of Paraguay in 1993 to that in 1999?
Your answer should be compact. 0.98. What is the ratio of the Value added (% of GDP) of Latin America(all income levels) in 1994 to that in 1995?
Provide a succinct answer. 1.11. What is the ratio of the Value added (% of GDP) in Jamaica in 1994 to that in 1995?
Offer a terse response. 1. What is the ratio of the Value added (% of GDP) in Nepal in 1994 to that in 1995?
Provide a short and direct response. 0.95. What is the ratio of the Value added (% of GDP) of Paraguay in 1994 to that in 1995?
Provide a succinct answer. 1.01. What is the ratio of the Value added (% of GDP) in Latin America(all income levels) in 1994 to that in 1996?
Your response must be concise. 1.08. What is the ratio of the Value added (% of GDP) in Jamaica in 1994 to that in 1996?
Provide a short and direct response. 1.07. What is the ratio of the Value added (% of GDP) of Nepal in 1994 to that in 1996?
Give a very brief answer. 0.95. What is the ratio of the Value added (% of GDP) of Paraguay in 1994 to that in 1996?
Give a very brief answer. 1.02. What is the ratio of the Value added (% of GDP) of Latin America(all income levels) in 1994 to that in 1997?
Provide a short and direct response. 1.08. What is the ratio of the Value added (% of GDP) in Jamaica in 1994 to that in 1997?
Give a very brief answer. 1.11. What is the ratio of the Value added (% of GDP) of Nepal in 1994 to that in 1997?
Offer a terse response. 0.95. What is the ratio of the Value added (% of GDP) in Paraguay in 1994 to that in 1997?
Your answer should be very brief. 1.03. What is the ratio of the Value added (% of GDP) of Latin America(all income levels) in 1994 to that in 1998?
Offer a terse response. 1.12. What is the ratio of the Value added (% of GDP) of Jamaica in 1994 to that in 1998?
Ensure brevity in your answer.  1.42. What is the ratio of the Value added (% of GDP) in Nepal in 1994 to that in 1998?
Provide a short and direct response. 0.97. What is the ratio of the Value added (% of GDP) in Paraguay in 1994 to that in 1998?
Your response must be concise. 1. What is the ratio of the Value added (% of GDP) of Latin America(all income levels) in 1994 to that in 1999?
Provide a succinct answer. 1.11. What is the ratio of the Value added (% of GDP) in Jamaica in 1994 to that in 1999?
Your answer should be compact. 1.41. What is the ratio of the Value added (% of GDP) in Nepal in 1994 to that in 1999?
Provide a succinct answer. 1. What is the ratio of the Value added (% of GDP) of Paraguay in 1994 to that in 1999?
Offer a terse response. 0.97. What is the ratio of the Value added (% of GDP) in Latin America(all income levels) in 1995 to that in 1996?
Your answer should be compact. 0.98. What is the ratio of the Value added (% of GDP) in Jamaica in 1995 to that in 1996?
Keep it short and to the point. 1.08. What is the ratio of the Value added (% of GDP) in Paraguay in 1995 to that in 1996?
Keep it short and to the point. 1.02. What is the ratio of the Value added (% of GDP) of Latin America(all income levels) in 1995 to that in 1997?
Your answer should be compact. 0.98. What is the ratio of the Value added (% of GDP) in Jamaica in 1995 to that in 1997?
Your answer should be very brief. 1.11. What is the ratio of the Value added (% of GDP) of Paraguay in 1995 to that in 1997?
Your response must be concise. 1.02. What is the ratio of the Value added (% of GDP) of Latin America(all income levels) in 1995 to that in 1998?
Your response must be concise. 1.01. What is the ratio of the Value added (% of GDP) of Jamaica in 1995 to that in 1998?
Your response must be concise. 1.42. What is the ratio of the Value added (% of GDP) in Nepal in 1995 to that in 1998?
Keep it short and to the point. 1.01. What is the ratio of the Value added (% of GDP) in Paraguay in 1995 to that in 1998?
Your response must be concise. 0.99. What is the ratio of the Value added (% of GDP) in Latin America(all income levels) in 1995 to that in 1999?
Your answer should be very brief. 1.01. What is the ratio of the Value added (% of GDP) in Jamaica in 1995 to that in 1999?
Offer a very short reply. 1.42. What is the ratio of the Value added (% of GDP) in Nepal in 1995 to that in 1999?
Provide a short and direct response. 1.04. What is the ratio of the Value added (% of GDP) in Paraguay in 1995 to that in 1999?
Your answer should be very brief. 0.96. What is the ratio of the Value added (% of GDP) in Latin America(all income levels) in 1996 to that in 1997?
Your answer should be very brief. 1. What is the ratio of the Value added (% of GDP) in Jamaica in 1996 to that in 1997?
Ensure brevity in your answer.  1.03. What is the ratio of the Value added (% of GDP) of Latin America(all income levels) in 1996 to that in 1998?
Provide a short and direct response. 1.03. What is the ratio of the Value added (% of GDP) of Jamaica in 1996 to that in 1998?
Your answer should be very brief. 1.32. What is the ratio of the Value added (% of GDP) of Nepal in 1996 to that in 1998?
Ensure brevity in your answer.  1.02. What is the ratio of the Value added (% of GDP) in Paraguay in 1996 to that in 1998?
Provide a succinct answer. 0.98. What is the ratio of the Value added (% of GDP) of Jamaica in 1996 to that in 1999?
Offer a very short reply. 1.31. What is the ratio of the Value added (% of GDP) of Nepal in 1996 to that in 1999?
Keep it short and to the point. 1.05. What is the ratio of the Value added (% of GDP) in Paraguay in 1996 to that in 1999?
Your answer should be very brief. 0.95. What is the ratio of the Value added (% of GDP) of Latin America(all income levels) in 1997 to that in 1998?
Offer a very short reply. 1.03. What is the ratio of the Value added (% of GDP) in Jamaica in 1997 to that in 1998?
Provide a short and direct response. 1.28. What is the ratio of the Value added (% of GDP) of Nepal in 1997 to that in 1998?
Offer a very short reply. 1.02. What is the ratio of the Value added (% of GDP) of Paraguay in 1997 to that in 1998?
Ensure brevity in your answer.  0.97. What is the ratio of the Value added (% of GDP) of Latin America(all income levels) in 1997 to that in 1999?
Your answer should be compact. 1.03. What is the ratio of the Value added (% of GDP) in Jamaica in 1997 to that in 1999?
Make the answer very short. 1.27. What is the ratio of the Value added (% of GDP) of Nepal in 1997 to that in 1999?
Provide a short and direct response. 1.05. What is the ratio of the Value added (% of GDP) in Paraguay in 1997 to that in 1999?
Your answer should be compact. 0.94. What is the ratio of the Value added (% of GDP) in Latin America(all income levels) in 1998 to that in 1999?
Your answer should be very brief. 1. What is the ratio of the Value added (% of GDP) of Jamaica in 1998 to that in 1999?
Give a very brief answer. 1. What is the ratio of the Value added (% of GDP) of Nepal in 1998 to that in 1999?
Your answer should be compact. 1.03. What is the ratio of the Value added (% of GDP) of Paraguay in 1998 to that in 1999?
Your answer should be very brief. 0.97. What is the difference between the highest and the second highest Value added (% of GDP) of Latin America(all income levels)?
Keep it short and to the point. 1.35. What is the difference between the highest and the second highest Value added (% of GDP) in Jamaica?
Your answer should be compact. 0.35. What is the difference between the highest and the second highest Value added (% of GDP) of Nepal?
Your answer should be compact. 0.05. What is the difference between the highest and the second highest Value added (% of GDP) in Paraguay?
Offer a terse response. 0.61. What is the difference between the highest and the lowest Value added (% of GDP) of Latin America(all income levels)?
Your answer should be very brief. 5.03. What is the difference between the highest and the lowest Value added (% of GDP) in Jamaica?
Give a very brief answer. 11.24. What is the difference between the highest and the lowest Value added (% of GDP) of Nepal?
Your response must be concise. 2.25. What is the difference between the highest and the lowest Value added (% of GDP) of Paraguay?
Your answer should be compact. 2.11. 